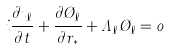Convert formula to latex. <formula><loc_0><loc_0><loc_500><loc_500>i \frac { \partial \zeta _ { \ell } } { \partial t } + \frac { \partial \chi _ { \ell } } { \partial r _ { * } } + \Lambda _ { \ell } \chi _ { \ell } = 0</formula> 